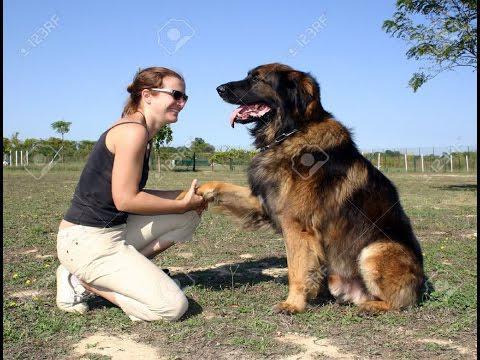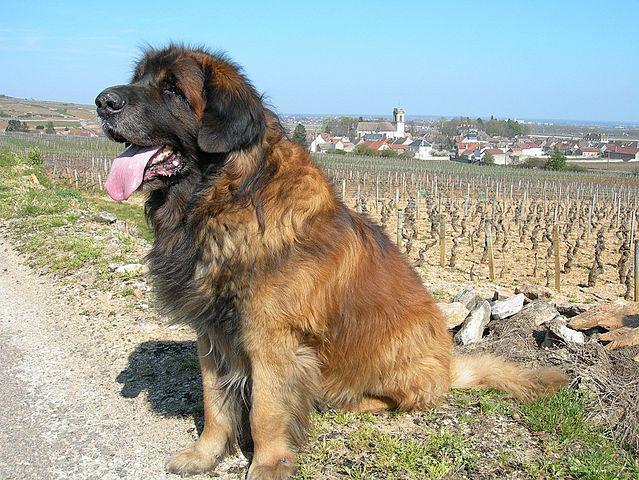The first image is the image on the left, the second image is the image on the right. Given the left and right images, does the statement "One of the dogs is alone in one of the pictures." hold true? Answer yes or no. Yes. 